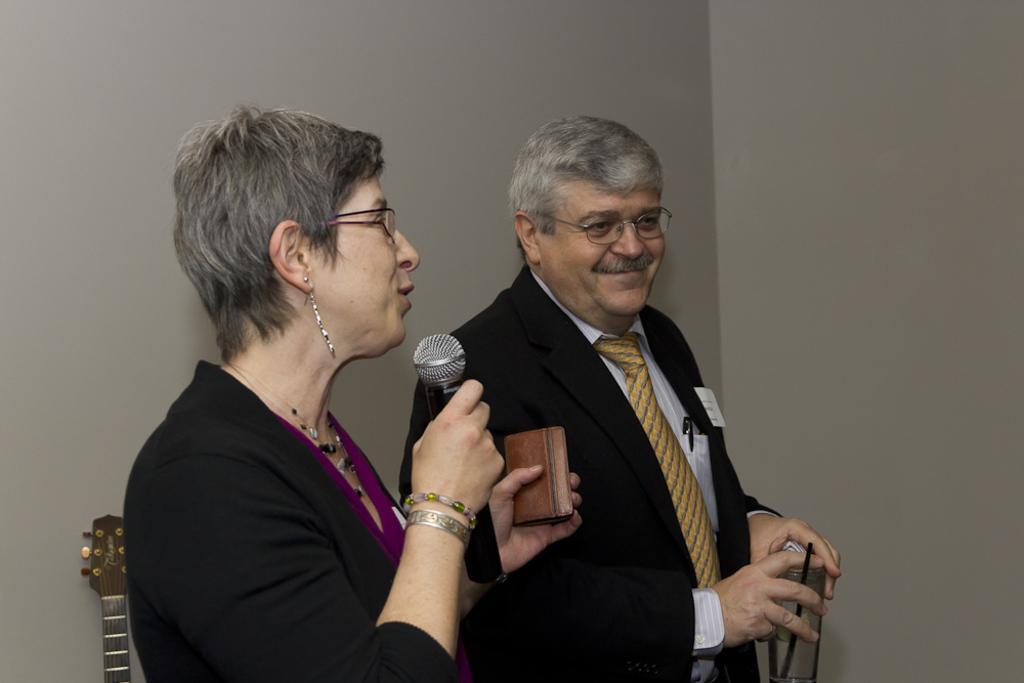How would you summarize this image in a sentence or two? In this picture we can see a man and a woman standing. We can see this women holding a mike in her hand and talking and this man is holding a glass with straw in his hand. Near to the wall there is a guitar. 